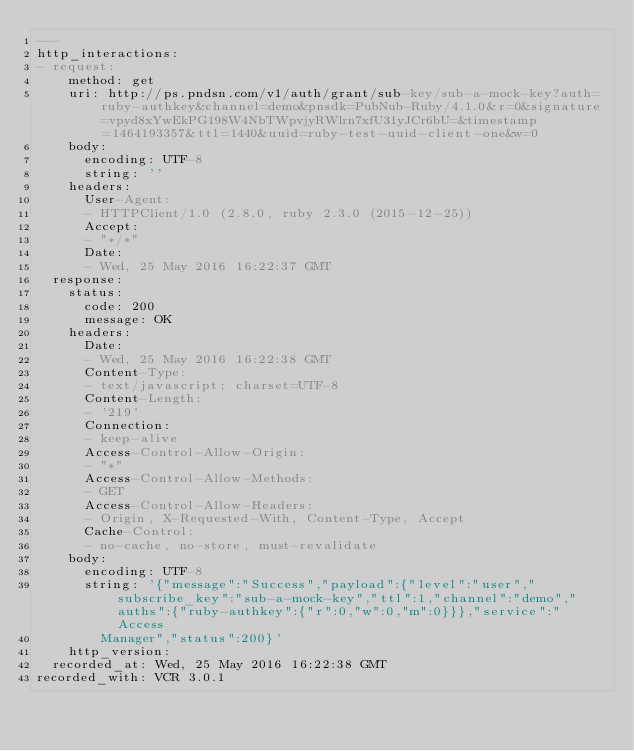<code> <loc_0><loc_0><loc_500><loc_500><_YAML_>---
http_interactions:
- request:
    method: get
    uri: http://ps.pndsn.com/v1/auth/grant/sub-key/sub-a-mock-key?auth=ruby-authkey&channel=demo&pnsdk=PubNub-Ruby/4.1.0&r=0&signature=vpyd8xYwEkPG198W4NbTWpvjyRWlrn7xfU31yJCr6bU=&timestamp=1464193357&ttl=1440&uuid=ruby-test-uuid-client-one&w=0
    body:
      encoding: UTF-8
      string: ''
    headers:
      User-Agent:
      - HTTPClient/1.0 (2.8.0, ruby 2.3.0 (2015-12-25))
      Accept:
      - "*/*"
      Date:
      - Wed, 25 May 2016 16:22:37 GMT
  response:
    status:
      code: 200
      message: OK
    headers:
      Date:
      - Wed, 25 May 2016 16:22:38 GMT
      Content-Type:
      - text/javascript; charset=UTF-8
      Content-Length:
      - '219'
      Connection:
      - keep-alive
      Access-Control-Allow-Origin:
      - "*"
      Access-Control-Allow-Methods:
      - GET
      Access-Control-Allow-Headers:
      - Origin, X-Requested-With, Content-Type, Accept
      Cache-Control:
      - no-cache, no-store, must-revalidate
    body:
      encoding: UTF-8
      string: '{"message":"Success","payload":{"level":"user","subscribe_key":"sub-a-mock-key","ttl":1,"channel":"demo","auths":{"ruby-authkey":{"r":0,"w":0,"m":0}}},"service":"Access
        Manager","status":200}'
    http_version: 
  recorded_at: Wed, 25 May 2016 16:22:38 GMT
recorded_with: VCR 3.0.1
</code> 